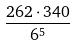Convert formula to latex. <formula><loc_0><loc_0><loc_500><loc_500>\frac { 2 6 2 \cdot 3 4 0 } { 6 ^ { 5 } }</formula> 